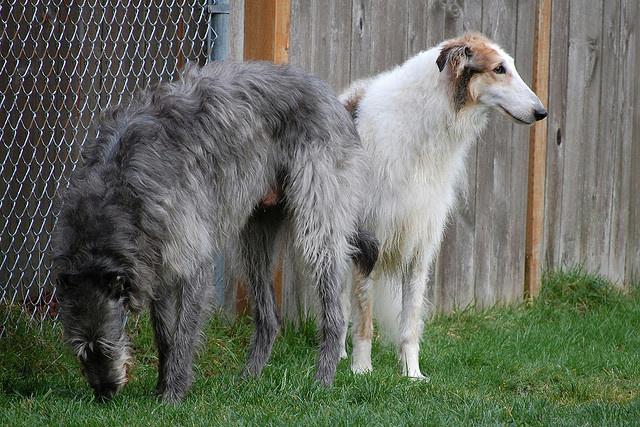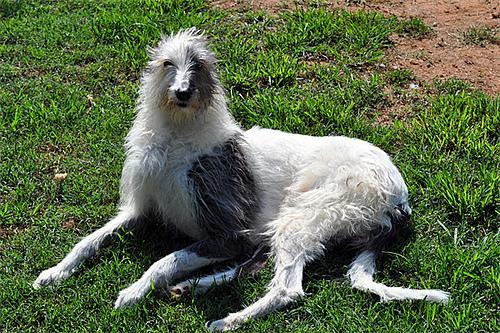The first image is the image on the left, the second image is the image on the right. For the images shown, is this caption "The left image contains exactly two dogs." true? Answer yes or no. Yes. The first image is the image on the left, the second image is the image on the right. Examine the images to the left and right. Is the description "All hounds are standing, and one image contains one rightward facing hound on a leash." accurate? Answer yes or no. No. 